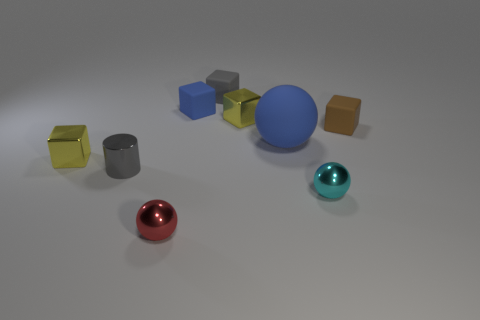How big is the blue thing right of the yellow shiny block that is to the right of the metal cube in front of the brown object?
Your response must be concise. Large. Is the number of red metallic spheres to the left of the red object greater than the number of big green cylinders?
Offer a very short reply. No. Is there a large green shiny thing?
Give a very brief answer. No. What number of brown cubes are the same size as the brown object?
Give a very brief answer. 0. Is the number of small cyan things that are on the right side of the cyan ball greater than the number of tiny gray metal cylinders to the left of the small red ball?
Make the answer very short. No. There is a cyan thing that is the same size as the gray metal cylinder; what is it made of?
Offer a terse response. Metal. What is the shape of the big blue rubber object?
Provide a succinct answer. Sphere. What number of brown things are either matte blocks or rubber spheres?
Offer a terse response. 1. What is the size of the cyan sphere that is the same material as the small red ball?
Provide a succinct answer. Small. Do the tiny sphere that is behind the red metal thing and the small ball that is to the left of the tiny gray matte object have the same material?
Give a very brief answer. Yes. 